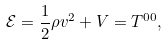Convert formula to latex. <formula><loc_0><loc_0><loc_500><loc_500>\mathcal { E } = \frac { 1 } { 2 } \rho { v } ^ { 2 } + V = T ^ { 0 0 } ,</formula> 